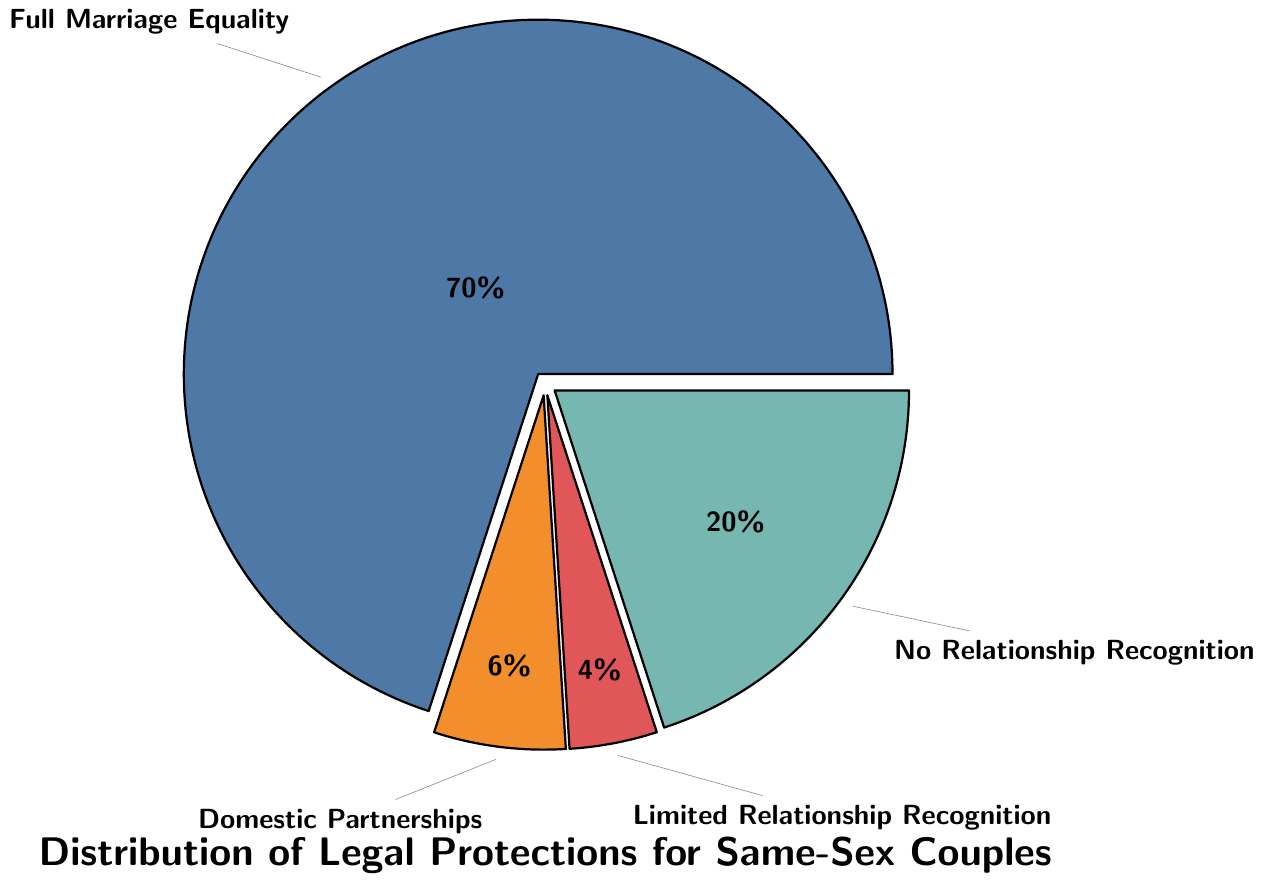Which category occupies the largest portion of the pie chart? The "Full Marriage Equality" segment is visibly the largest part of the pie chart.
Answer: Full Marriage Equality What percentage of states have no relationship recognition for same-sex couples? The "No Relationship Recognition" segment is labeled as 20% on the pie chart.
Answer: 20% How many times larger is the Full Marriage Equality category compared to Domestic Partnerships/Civil Unions? The Full Marriage Equality category is 70%, and Domestic Partnerships/Civil Unions is 6%. To find out how many times larger, divide 70 by 6. \( \frac{70}{6} = 11.67 \)
Answer: 11.67 times Which two categories combined account for the smallest percentage of states? The "Domestic Partnerships/Civil Unions" (6%) and "Limited Relationship Recognition" (4%) segments together account for \( 6 + 4 = 10\% \).
Answer: Domestic Partnerships/Civil Unions and Limited Relationship Recognition Do more states recognize same-sex marriage fully or have no relationship recognition at all? Compare the percentages: "Full Marriage Equality" is 70%, while "No Relationship Recognition" is 20%. 70% is greater than 20%.
Answer: More states recognize same-sex marriage fully What is the combined percentage of states that offer either Limited Relationship Recognition or No Relationship Recognition? Add the percentages of "Limited Relationship Recognition" (4%) and "No Relationship Recognition" (20%). \( 4 + 20 = 24\% \)
Answer: 24% Is the percentage of states that recognize Full Marriage Equality greater than all other categories combined? Combine the percentages of all other categories: 6% (Domestic Partnerships) + 4% (Limited) + 20% (No Recognition) = 30%. Compare this to 70% (Full Marriage Equality). 70% is greater than 30%.
Answer: Yes How much larger is the percentage of Domestic Partnerships/Civil Unions compared to Limited Relationship Recognition? Subtract the percentage of Limited Relationship Recognition (4%) from Domestic Partnerships/Civil Unions (6%). \( 6 - 4 = 2 \)
Answer: 2% What is the difference in percentage between states with Full Marriage Equality and those with No Relationship Recognition? Subtract the percentage of No Relationship Recognition (20%) from Full Marriage Equality (70%). \( 70 - 20 = 50 \)
Answer: 50% What colors represent each category on the pie chart? The pie chart features the following colors: Blue for Full Marriage Equality, Orange for Domestic Partnerships/Civil Unions, Red for Limited Relationship Recognition, and Green for No Relationship Recognition.
Answer: Blue; Orange; Red; Green 